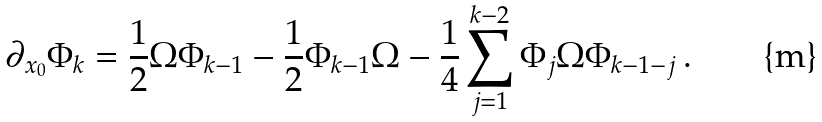Convert formula to latex. <formula><loc_0><loc_0><loc_500><loc_500>\partial _ { x _ { 0 } } \Phi _ { k } = \frac { 1 } { 2 } \Omega \Phi _ { k - 1 } - \frac { 1 } { 2 } \Phi _ { k - 1 } \Omega - \frac { 1 } { 4 } \sum _ { j = 1 } ^ { k - 2 } \Phi _ { j } \Omega \Phi _ { k - 1 - j } \, .</formula> 